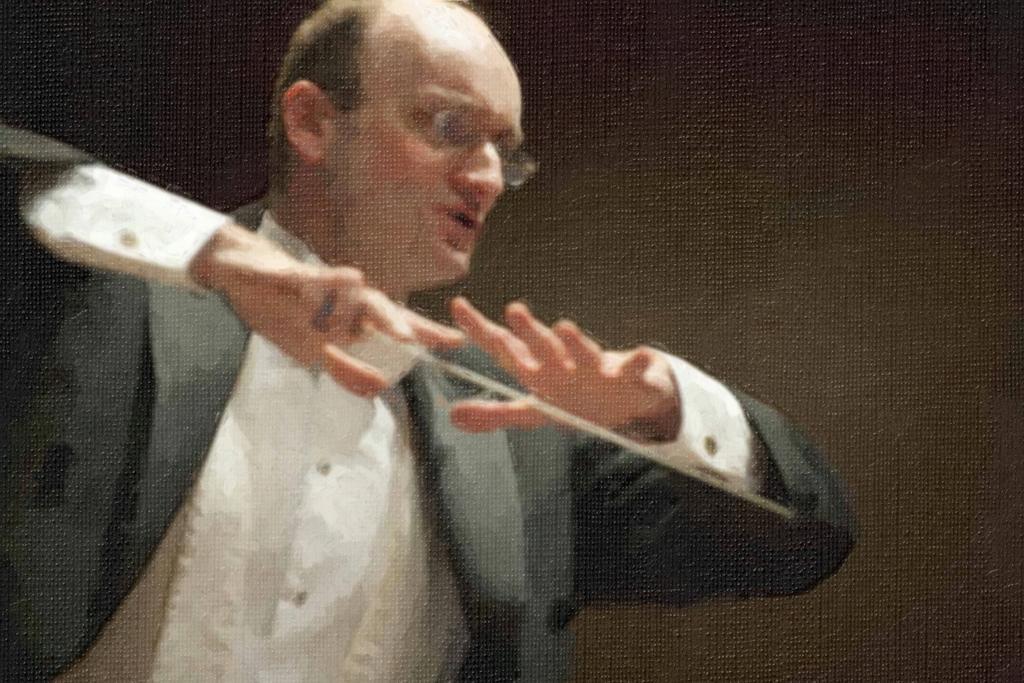How would you summarize this image in a sentence or two? In this image I can see the person wearing the blazer and shirt. The person is holding the stick. And there is a black background. 